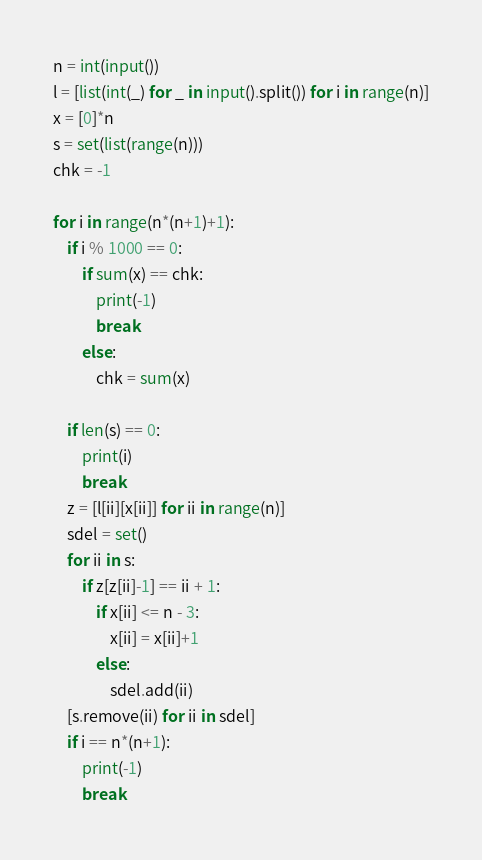<code> <loc_0><loc_0><loc_500><loc_500><_Python_>n = int(input())
l = [list(int(_) for _ in input().split()) for i in range(n)]
x = [0]*n
s = set(list(range(n)))
chk = -1

for i in range(n*(n+1)+1):
    if i % 1000 == 0:
        if sum(x) == chk:
            print(-1)
            break
        else:
            chk = sum(x)
    
    if len(s) == 0:
        print(i)
        break
    z = [l[ii][x[ii]] for ii in range(n)]
    sdel = set()
    for ii in s:
        if z[z[ii]-1] == ii + 1:
            if x[ii] <= n - 3:
                x[ii] = x[ii]+1
            else:
                sdel.add(ii)
    [s.remove(ii) for ii in sdel]
    if i == n*(n+1):
        print(-1)
        break
</code> 